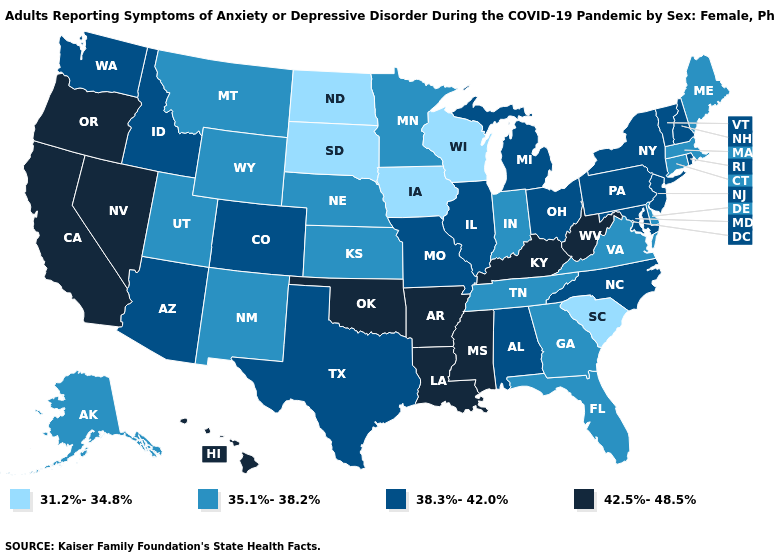Does South Carolina have the lowest value in the South?
Keep it brief. Yes. What is the value of Georgia?
Write a very short answer. 35.1%-38.2%. Name the states that have a value in the range 42.5%-48.5%?
Be succinct. Arkansas, California, Hawaii, Kentucky, Louisiana, Mississippi, Nevada, Oklahoma, Oregon, West Virginia. Name the states that have a value in the range 42.5%-48.5%?
Give a very brief answer. Arkansas, California, Hawaii, Kentucky, Louisiana, Mississippi, Nevada, Oklahoma, Oregon, West Virginia. Name the states that have a value in the range 35.1%-38.2%?
Short answer required. Alaska, Connecticut, Delaware, Florida, Georgia, Indiana, Kansas, Maine, Massachusetts, Minnesota, Montana, Nebraska, New Mexico, Tennessee, Utah, Virginia, Wyoming. Does Connecticut have the highest value in the Northeast?
Keep it brief. No. What is the value of Wyoming?
Short answer required. 35.1%-38.2%. How many symbols are there in the legend?
Answer briefly. 4. Name the states that have a value in the range 31.2%-34.8%?
Be succinct. Iowa, North Dakota, South Carolina, South Dakota, Wisconsin. Name the states that have a value in the range 38.3%-42.0%?
Keep it brief. Alabama, Arizona, Colorado, Idaho, Illinois, Maryland, Michigan, Missouri, New Hampshire, New Jersey, New York, North Carolina, Ohio, Pennsylvania, Rhode Island, Texas, Vermont, Washington. Name the states that have a value in the range 42.5%-48.5%?
Be succinct. Arkansas, California, Hawaii, Kentucky, Louisiana, Mississippi, Nevada, Oklahoma, Oregon, West Virginia. Is the legend a continuous bar?
Answer briefly. No. Name the states that have a value in the range 31.2%-34.8%?
Give a very brief answer. Iowa, North Dakota, South Carolina, South Dakota, Wisconsin. What is the lowest value in the USA?
Quick response, please. 31.2%-34.8%. 